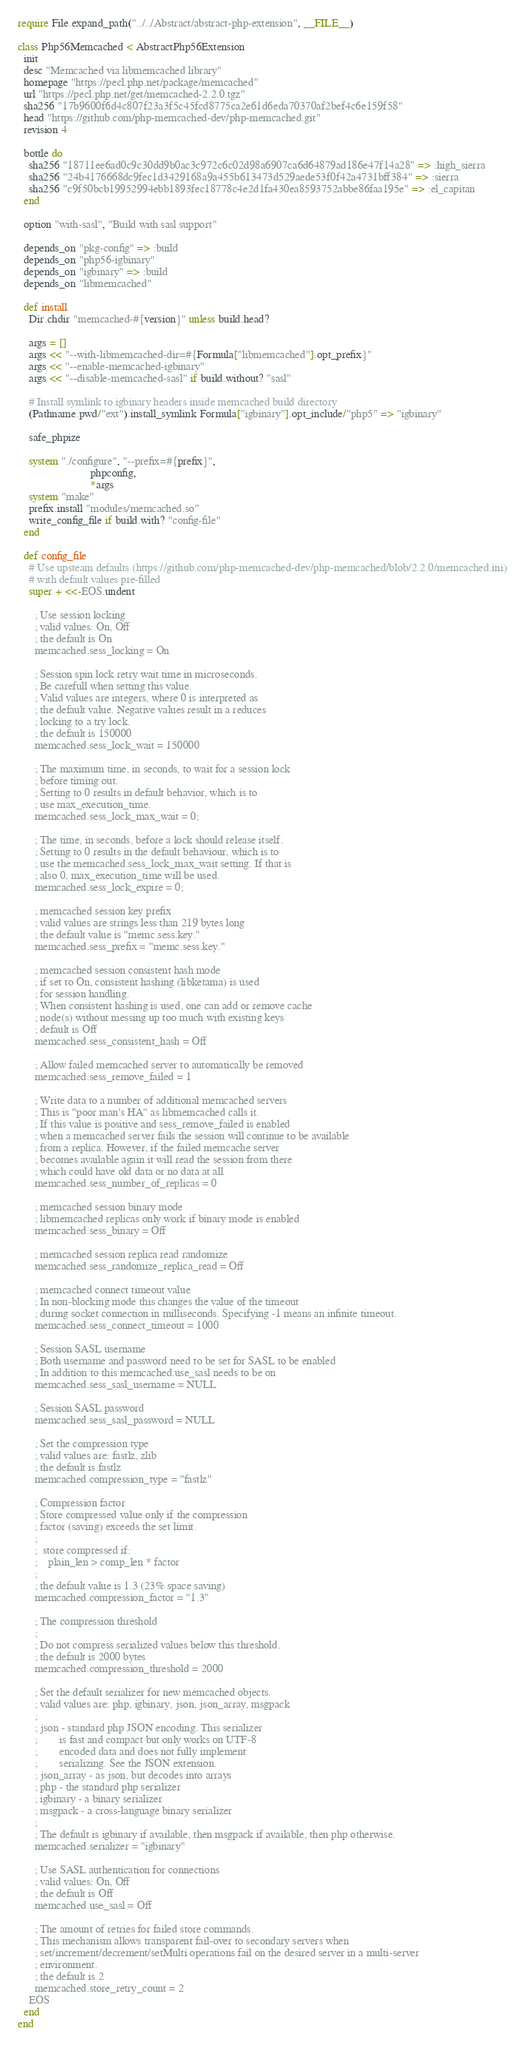<code> <loc_0><loc_0><loc_500><loc_500><_Ruby_>require File.expand_path("../../Abstract/abstract-php-extension", __FILE__)

class Php56Memcached < AbstractPhp56Extension
  init
  desc "Memcached via libmemcached library"
  homepage "https://pecl.php.net/package/memcached"
  url "https://pecl.php.net/get/memcached-2.2.0.tgz"
  sha256 "17b9600f6d4c807f23a3f5c45fcd8775ca2e61d6eda70370af2bef4c6e159f58"
  head "https://github.com/php-memcached-dev/php-memcached.git"
  revision 4

  bottle do
    sha256 "18711ee6ad0c9c30dd9b0ac3c972c6c02d98a6907ca6d64879ad186e47f14a28" => :high_sierra
    sha256 "24b4176668dc9fec1d3429168a9a455b613473d529aede53f0f42a4731bff384" => :sierra
    sha256 "c9f50bcb19952994ebb1893fec18778c4e2d1fa430ea8593752abbe86faa195e" => :el_capitan
  end

  option "with-sasl", "Build with sasl support"

  depends_on "pkg-config" => :build
  depends_on "php56-igbinary"
  depends_on "igbinary" => :build
  depends_on "libmemcached"

  def install
    Dir.chdir "memcached-#{version}" unless build.head?

    args = []
    args << "--with-libmemcached-dir=#{Formula["libmemcached"].opt_prefix}"
    args << "--enable-memcached-igbinary"
    args << "--disable-memcached-sasl" if build.without? "sasl"

    # Install symlink to igbinary headers inside memcached build directory
    (Pathname.pwd/"ext").install_symlink Formula["igbinary"].opt_include/"php5" => "igbinary"

    safe_phpize

    system "./configure", "--prefix=#{prefix}",
                          phpconfig,
                          *args
    system "make"
    prefix.install "modules/memcached.so"
    write_config_file if build.with? "config-file"
  end

  def config_file
    # Use upsteam defaults (https://github.com/php-memcached-dev/php-memcached/blob/2.2.0/memcached.ini)
    # with default values pre-filled
    super + <<-EOS.undent

      ; Use session locking
      ; valid values: On, Off
      ; the default is On
      memcached.sess_locking = On

      ; Session spin lock retry wait time in microseconds.
      ; Be carefull when setting this value.
      ; Valid values are integers, where 0 is interpreted as
      ; the default value. Negative values result in a reduces
      ; locking to a try lock.
      ; the default is 150000
      memcached.sess_lock_wait = 150000

      ; The maximum time, in seconds, to wait for a session lock
      ; before timing out.
      ; Setting to 0 results in default behavior, which is to
      ; use max_execution_time.
      memcached.sess_lock_max_wait = 0;

      ; The time, in seconds, before a lock should release itself.
      ; Setting to 0 results in the default behaviour, which is to
      ; use the memcached.sess_lock_max_wait setting. If that is
      ; also 0, max_execution_time will be used.
      memcached.sess_lock_expire = 0;

      ; memcached session key prefix
      ; valid values are strings less than 219 bytes long
      ; the default value is "memc.sess.key."
      memcached.sess_prefix = "memc.sess.key."

      ; memcached session consistent hash mode
      ; if set to On, consistent hashing (libketama) is used
      ; for session handling.
      ; When consistent hashing is used, one can add or remove cache
      ; node(s) without messing up too much with existing keys
      ; default is Off
      memcached.sess_consistent_hash = Off

      ; Allow failed memcached server to automatically be removed
      memcached.sess_remove_failed = 1

      ; Write data to a number of additional memcached servers
      ; This is "poor man's HA" as libmemcached calls it.
      ; If this value is positive and sess_remove_failed is enabled
      ; when a memcached server fails the session will continue to be available
      ; from a replica. However, if the failed memcache server
      ; becomes available again it will read the session from there
      ; which could have old data or no data at all
      memcached.sess_number_of_replicas = 0

      ; memcached session binary mode
      ; libmemcached replicas only work if binary mode is enabled
      memcached.sess_binary = Off

      ; memcached session replica read randomize
      memcached.sess_randomize_replica_read = Off

      ; memcached connect timeout value
      ; In non-blocking mode this changes the value of the timeout
      ; during socket connection in milliseconds. Specifying -1 means an infinite timeout.
      memcached.sess_connect_timeout = 1000

      ; Session SASL username
      ; Both username and password need to be set for SASL to be enabled
      ; In addition to this memcached.use_sasl needs to be on
      memcached.sess_sasl_username = NULL

      ; Session SASL password
      memcached.sess_sasl_password = NULL

      ; Set the compression type
      ; valid values are: fastlz, zlib
      ; the default is fastlz
      memcached.compression_type = "fastlz"

      ; Compression factor
      ; Store compressed value only if the compression
      ; factor (saving) exceeds the set limit.
      ;
      ;  store compressed if:
      ;    plain_len > comp_len * factor
      ;
      ; the default value is 1.3 (23% space saving)
      memcached.compression_factor = "1.3"

      ; The compression threshold
      ;
      ; Do not compress serialized values below this threshold.
      ; the default is 2000 bytes
      memcached.compression_threshold = 2000

      ; Set the default serializer for new memcached objects.
      ; valid values are: php, igbinary, json, json_array, msgpack
      ;
      ; json - standard php JSON encoding. This serializer
      ;        is fast and compact but only works on UTF-8
      ;        encoded data and does not fully implement
      ;        serializing. See the JSON extension.
      ; json_array - as json, but decodes into arrays
      ; php - the standard php serializer
      ; igbinary - a binary serializer
      ; msgpack - a cross-language binary serializer
      ;
      ; The default is igbinary if available, then msgpack if available, then php otherwise.
      memcached.serializer = "igbinary"

      ; Use SASL authentication for connections
      ; valid values: On, Off
      ; the default is Off
      memcached.use_sasl = Off

      ; The amount of retries for failed store commands.
      ; This mechanism allows transparent fail-over to secondary servers when
      ; set/increment/decrement/setMulti operations fail on the desired server in a multi-server
      ; environment.
      ; the default is 2
      memcached.store_retry_count = 2
    EOS
  end
end
</code> 